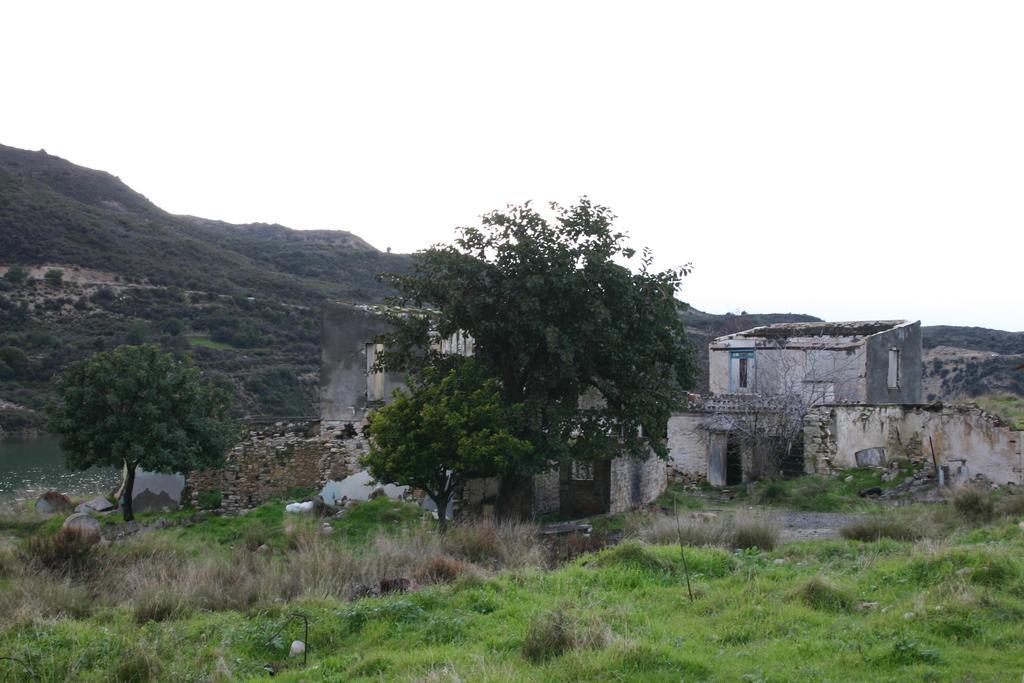Describe this image in one or two sentences. In this image we can see some buildings with windows. We can also see some grass, plants, trees and a water body. On the backside we can see a group of trees on the hills and the sky which looks cloudy. 